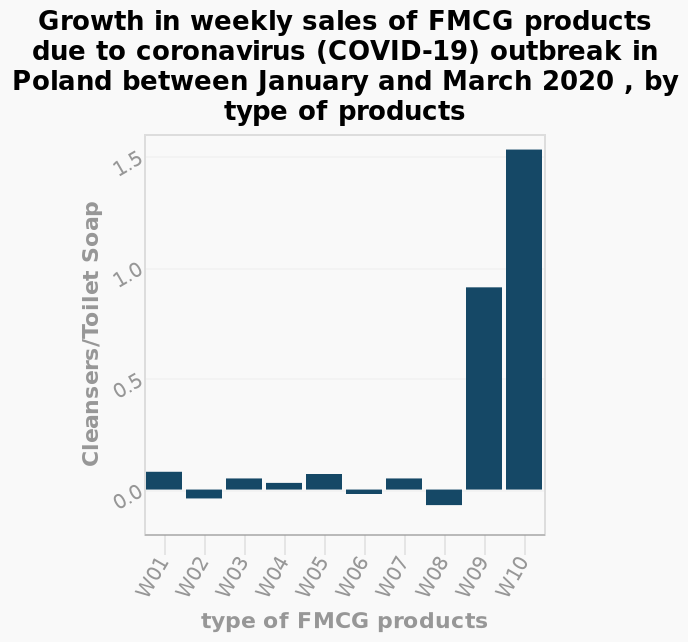<image>
Which specific product category is shown on the y-axis?  The specific product category shown on the y-axis is Cleansers/Toilet Soap. When did FMCG products experience significant growth in sales?  FMCG products saw enormous growth in weekly sales at the start of the coronavirus outbreak around the first week of March 2020. 